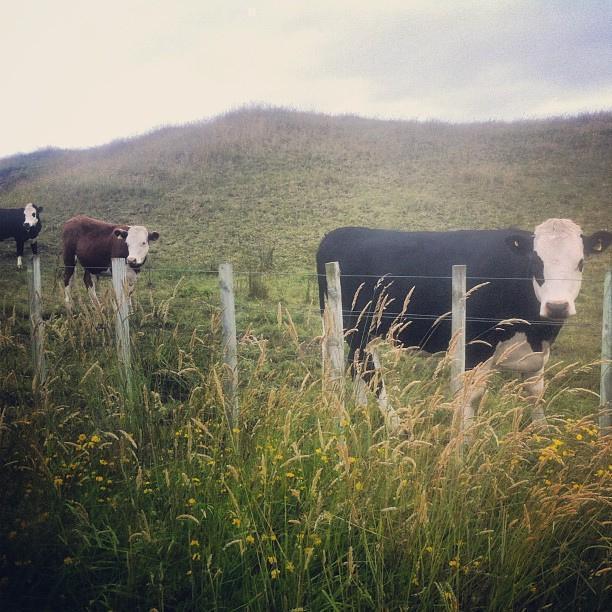What color is the cow in between the two milkcows?
Pick the correct solution from the four options below to address the question.
Options: Brown, ginger, green, pink. Brown. 